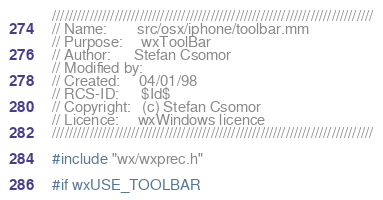Convert code to text. <code><loc_0><loc_0><loc_500><loc_500><_ObjectiveC_>/////////////////////////////////////////////////////////////////////////////
// Name:        src/osx/iphone/toolbar.mm
// Purpose:     wxToolBar
// Author:      Stefan Csomor
// Modified by:
// Created:     04/01/98
// RCS-ID:      $Id$
// Copyright:   (c) Stefan Csomor
// Licence:     wxWindows licence
/////////////////////////////////////////////////////////////////////////////

#include "wx/wxprec.h"

#if wxUSE_TOOLBAR
</code> 